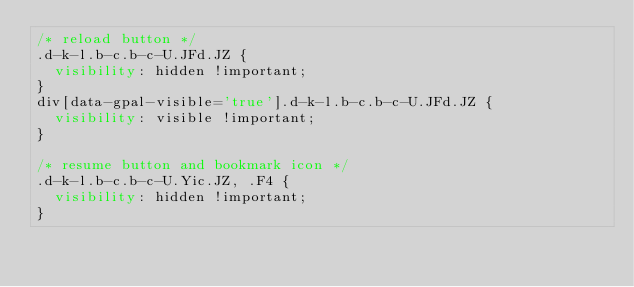<code> <loc_0><loc_0><loc_500><loc_500><_CSS_>/* reload button */
.d-k-l.b-c.b-c-U.JFd.JZ {
  visibility: hidden !important;
}
div[data-gpal-visible='true'].d-k-l.b-c.b-c-U.JFd.JZ {
  visibility: visible !important;
}

/* resume button and bookmark icon */
.d-k-l.b-c.b-c-U.Yic.JZ, .F4 {
  visibility: hidden !important;
}
</code> 